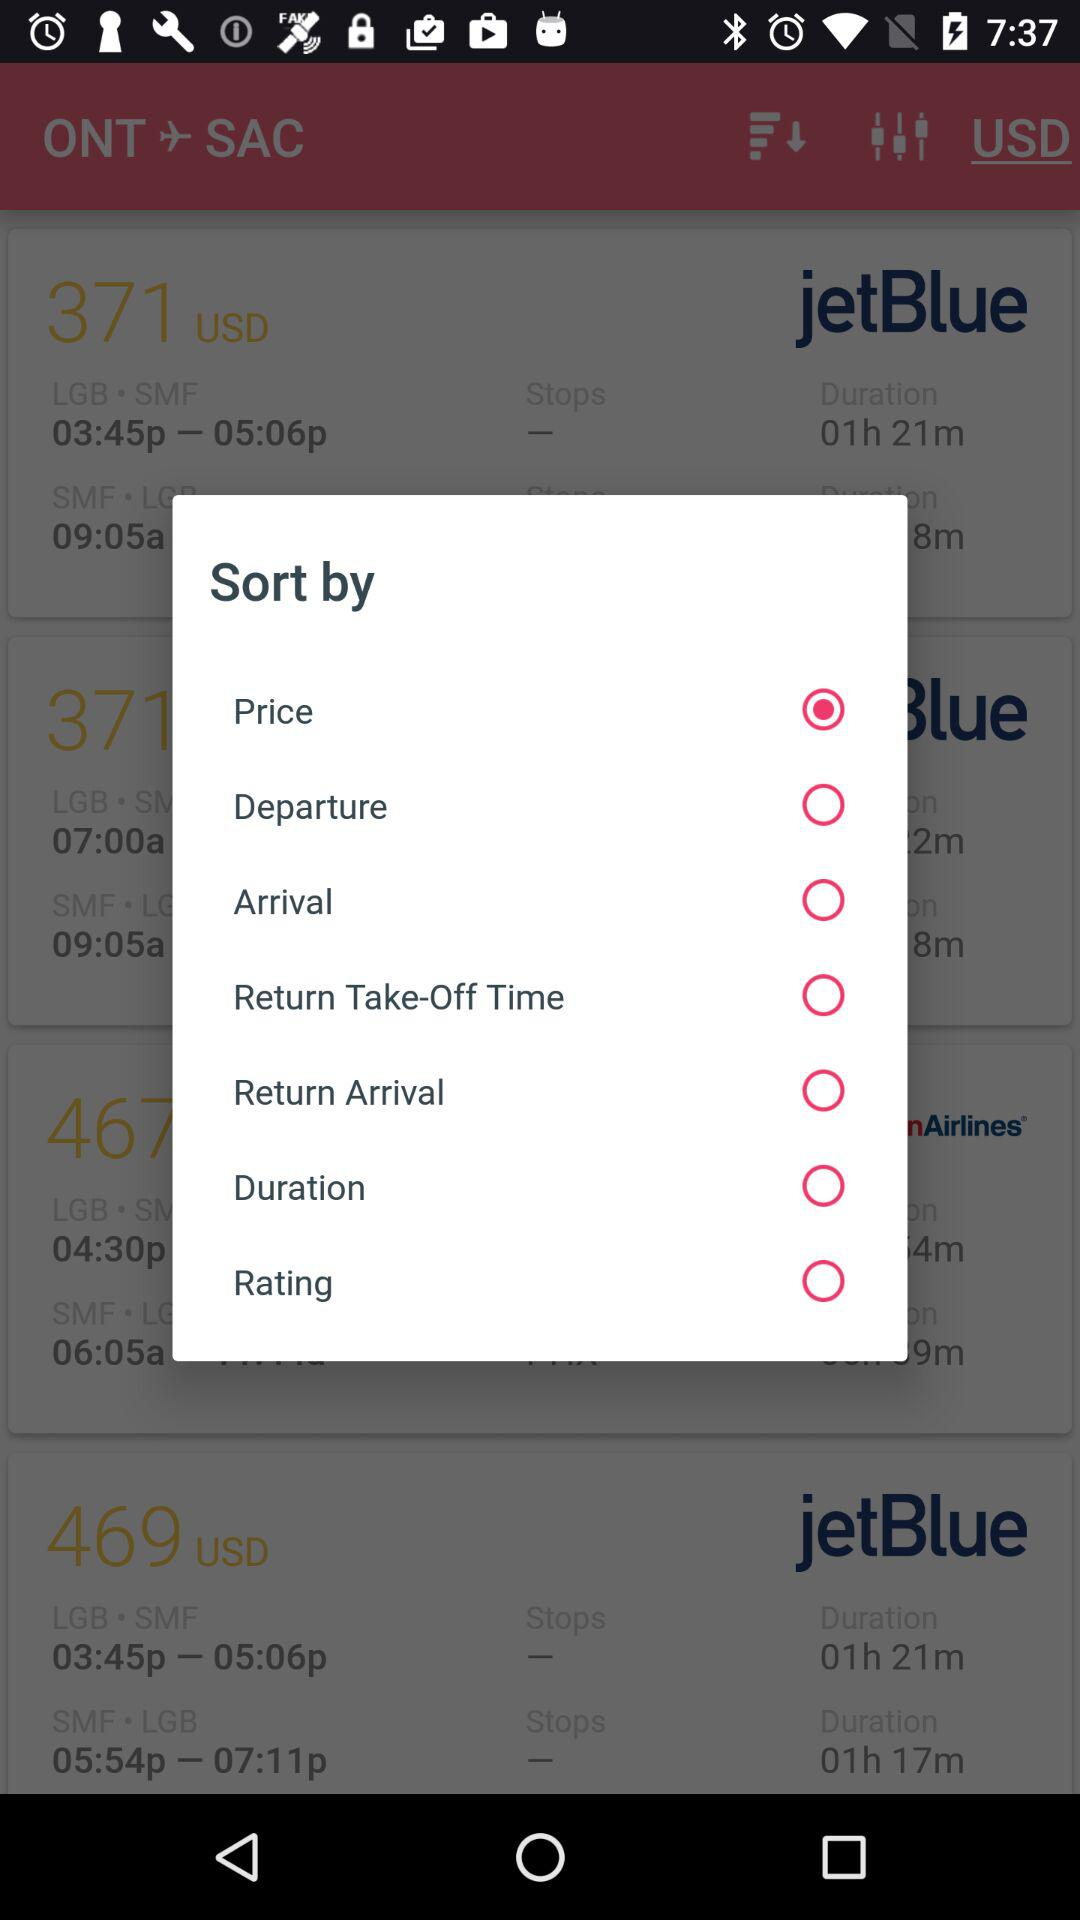What's the selected "Sort by" option? The selected "Sort by" option is "Price". 